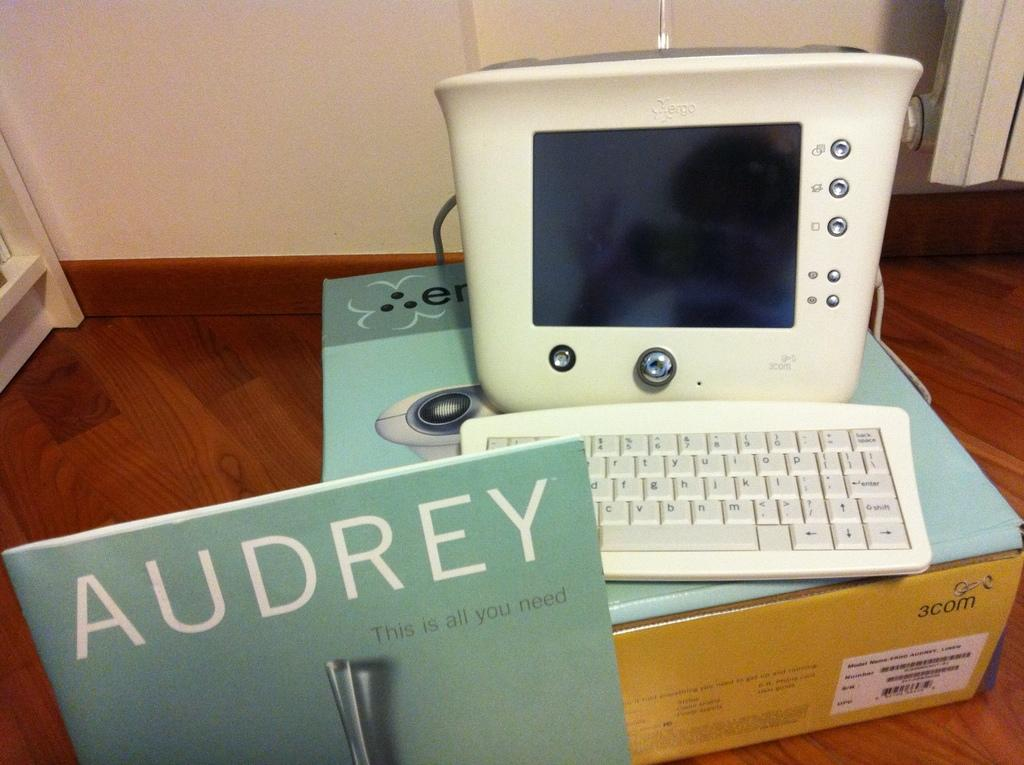<image>
Provide a brief description of the given image. The sign for Audrey claims that this is all she needs. 